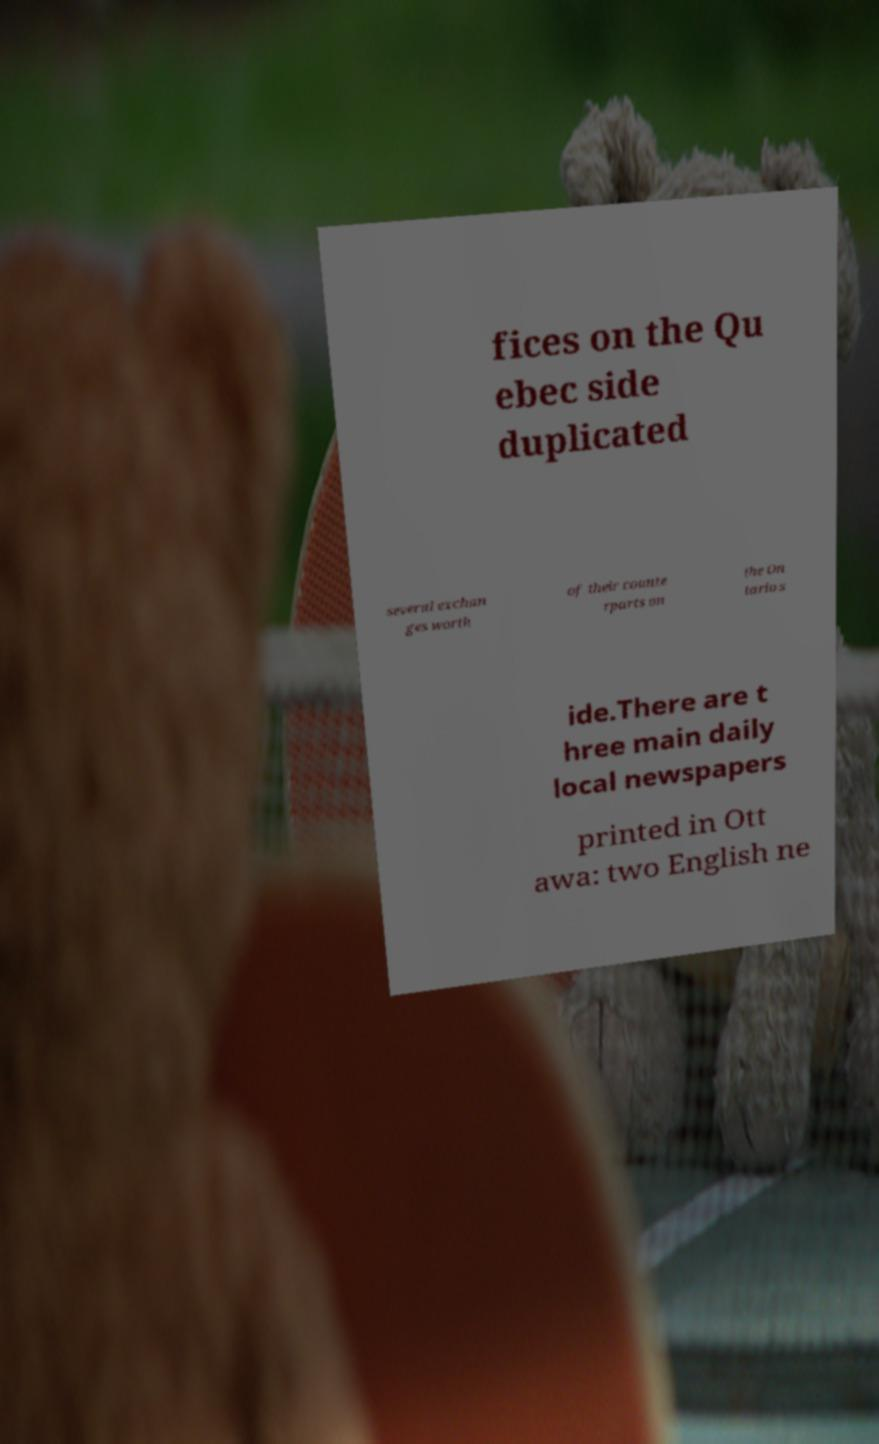I need the written content from this picture converted into text. Can you do that? fices on the Qu ebec side duplicated several exchan ges worth of their counte rparts on the On tario s ide.There are t hree main daily local newspapers printed in Ott awa: two English ne 